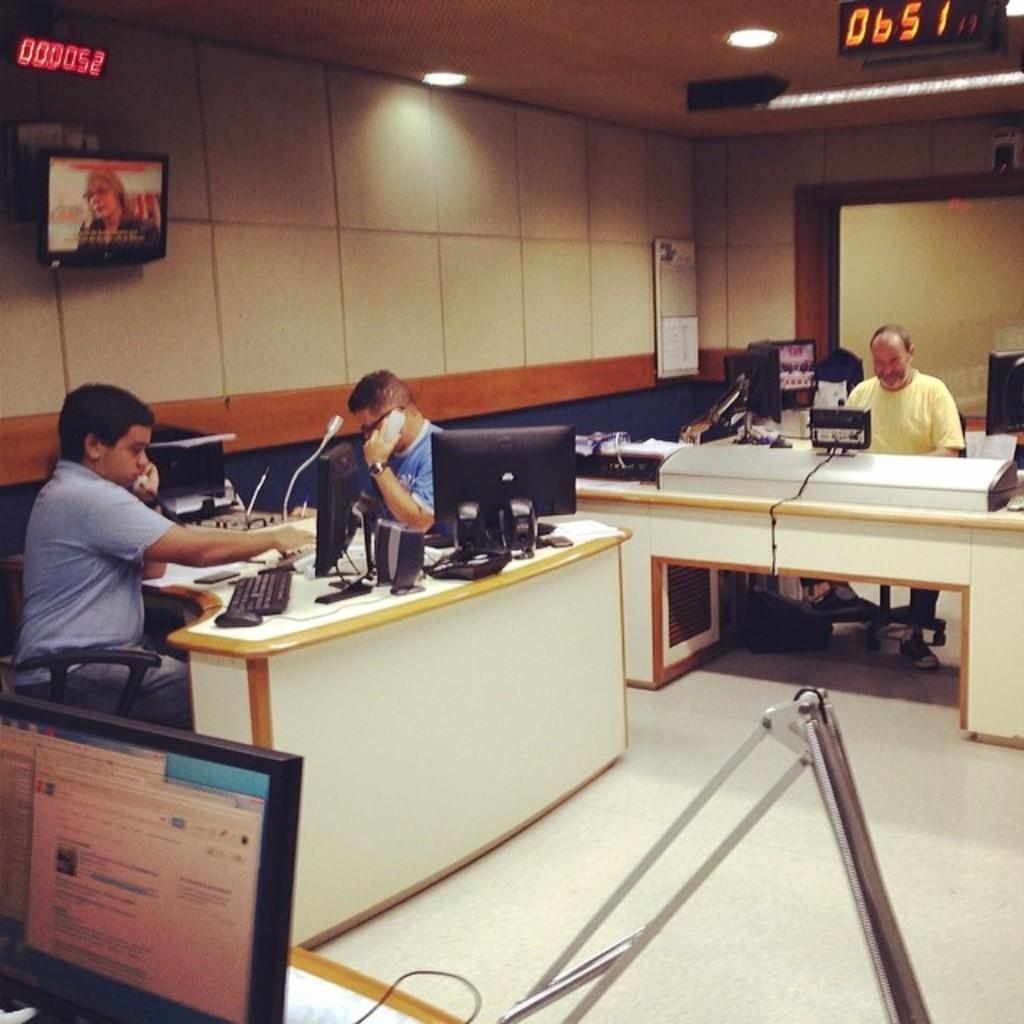What are the men in the image doing? The men in the image are sitting at a desk and working with their desktops. Can you describe the setting where the men are working? The men are sitting at a desk, which suggests they might be in an office or workspace. What is on the wall in the image? There is a TV on the wall. How many lizards can be seen swimming in the ocean in the image? There are no lizards or ocean present in the image; it features men sitting at a desk and working with their desktops, along with a TV on the wall. 